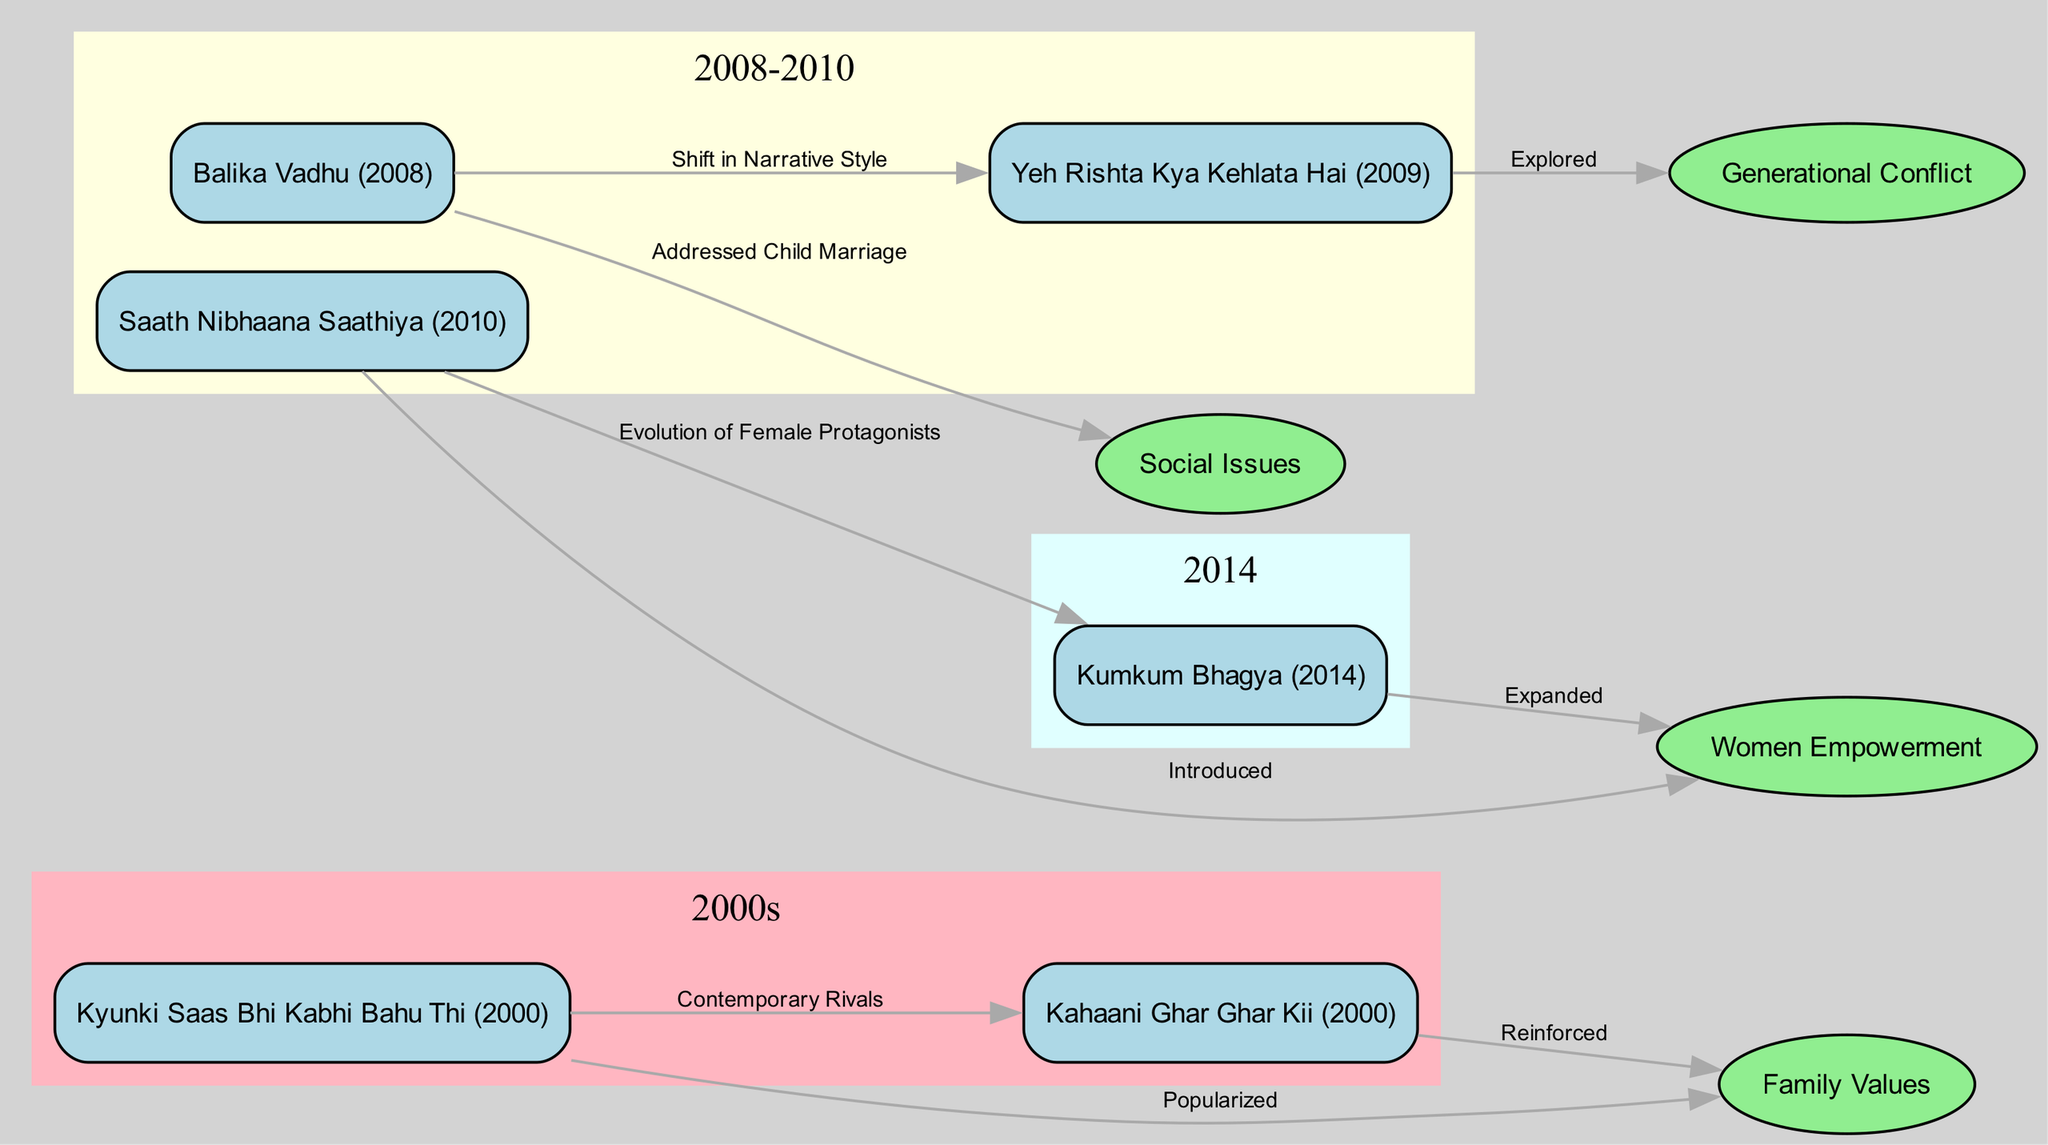What soap opera is associated with the theme of Women Empowerment? To find the answer, locate the node labeled "Women Empowerment" and trace the edge that connects it to the soap operas. The only soap opera that connects to this theme is "Saath Nibhaana Saathiya" (2010), which is indicated by the edge labeled "Introduced".
Answer: Saath Nibhaana Saathiya (2010) How many themes are represented in the diagram? Count the nodes that are of type "Theme". There are four nodes labeled "Family Values", "Women Empowerment", "Social Issues", and "Generational Conflict". This makes a total of four distinct themes represented in the diagram.
Answer: 4 Which soap opera explored the theme of Generational Conflict? Identify the node for "Generational Conflict" and find out which soap operas are connected to it. The soap opera "Yeh Rishta Kya Kehlata Hai" (2009) is connected to this theme through the edge labeled "Explored".
Answer: Yeh Rishta Kya Kehlata Hai (2009) What is the relationship between "Kyunki Saas Bhi Kabhi Bahu Thi" and "Kahaani Ghar Ghar Kii"? The two soap operas are connected by the edge labeled "Contemporary Rivals". This indicates that these shows were popular at the same time and could be viewed as competitors in the television landscape.
Answer: Contemporary Rivals What significant narrative change is noted between "Balika Vadhu" and "Yeh Rishta Kya Kehlata Hai"? To answer this question, trace the connection between "Balika Vadhu" and "Yeh Rishta Kya Kehlata Hai", which is indicated by the edge labeled "Shift in Narrative Style". This suggests that there was a noticeable evolution in storytelling techniques from one to the other.
Answer: Shift in Narrative Style How many soap operas were introduced after 2000 but before 2014? Analyze the nodes within the 2008-2010 cluster, which includes "Balika Vadhu" (2008), "Yeh Rishta Kya Kehlata Hai" (2009), and "Saath Nibhaana Saathiya" (2010). These three soap operas all fit the criteria of being introduced after 2000 and before 2014.
Answer: 3 Which theme did "Kumkum Bhagya" (2014) expand upon? Find the node for "Kumkum Bhagya" and follow the edge that leads from it to a theme. The edge labeled "Expanded" connects it to "Women Empowerment", indicating that this soap opera elaborated on this particular theme.
Answer: Women Empowerment Which soap opera addressed child marriage? Locate the node for "Balika Vadhu" (2008) and trace the edge that connects it to a theme. The edge labeled "Addressed Child Marriage" directly links to the theme of "Social Issues", making it clear that "Balika Vadhu" took on this serious societal issue.
Answer: Balika Vadhu (2008) 